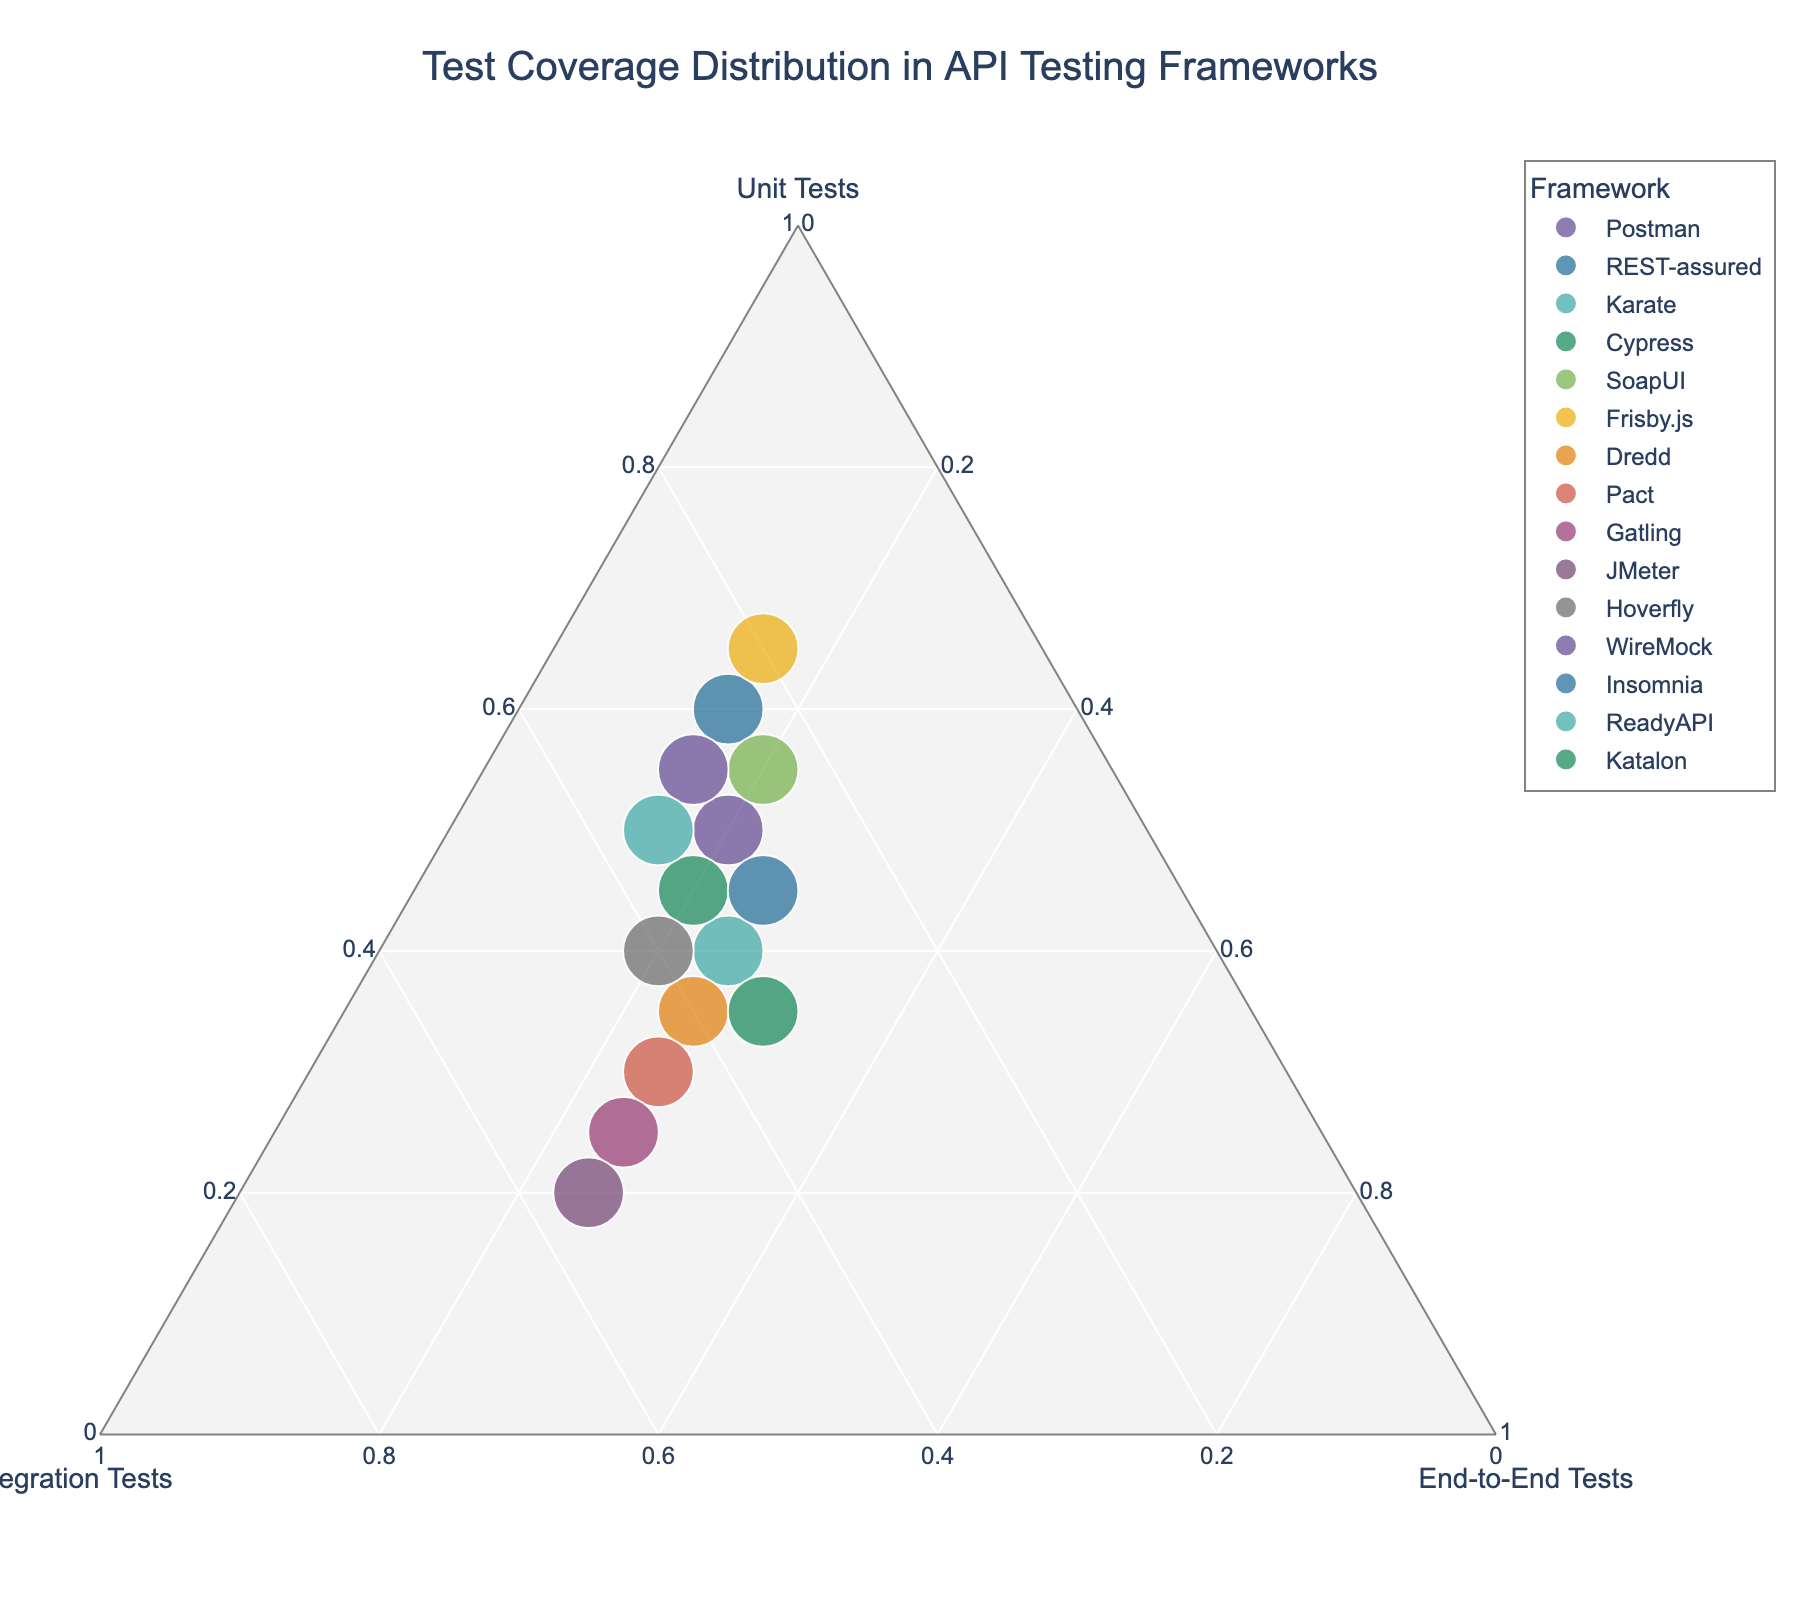How many frameworks have higher than 50% of their tests as unit tests? From the plot, percentages above 50% for unit tests can be identified by points positioned more towards the "Unit Tests" vertex. Examining these points gives us the frameworks Postman, REST-assured, SoapUI, Frisby.js, WireMock, and ReadyAPI.
Answer: 6 Which framework has the highest proportion of integration tests? By looking at the plot, the framework closest to the "Integration Tests" vertex has the highest proportion of integration tests. This point corresponds to JMeter.
Answer: JMeter For which framework is the test coverage most evenly distributed among unit tests, integration tests, and end-to-end tests? Even distribution would mean the point is closest to the center of the ternary plot, indicating equal proportions. The framework closest to the center is Katalon.
Answer: Katalon Which framework has the smallest total number of tests? The size of the points on the plot represents the total number of tests. The smallest point corresponds to Dredd.
Answer: Dredd What is the main testing focus (unit, integration, or end-to-end) of Gatling? The positioning of Gatling's point reveals it's closer to the "Integration Tests" vertex. Thus, Gatling's main focus is integration tests.
Answer: Integration Tests Compare the proportion of end-to-end tests for Karate and Insomnia. Which one has a higher proportion? By observing the points for Karate and Insomnia, Karate is slightly closer to the "End-to-End Tests" vertex compared to Insomnia. Therefore, Karate has a higher proportion of end-to-end tests.
Answer: Karate Among the frameworks positioned closer to the vertex for unit tests, which has the second largest total number of tests? Focusing on frameworks near the "Unit Tests" vertex, and examining the sizes of these points, we observe that the second-largest point is for WireMock, with the largest being Frisby.js.
Answer: WireMock Which frameworks have exactly 25% of their tests as end-to-end tests? Encoded in the proportion of end-to-end tests, the points that fall precisely at 25% are those for Karate, Pact, Gatling, Dredd, and Insomnia.
Answer: Karate, Pact, Gatling, Dredd, Insomnia What is the common characteristic of integration test proportions for the frameworks REST-assured, SoapUI, and WireMock? Analyzing the position of these frameworks, they all have their proportions for integration tests at around 25%, as depicted by their coordinates on the ternary plot.
Answer: Around 25% For frameworks with 50% or more integration tests, are unit or end-to-end tests generally higher in proportion, and which framework does this apply to? Observing points with 50% or more for integration tests, such as JMeter and Gatling, shows end-to-end tests are generally equal or higher than unit tests. Both JMeter and Gatling fit this observation.
Answer: End-to-end tests, JMeter and Gatling 